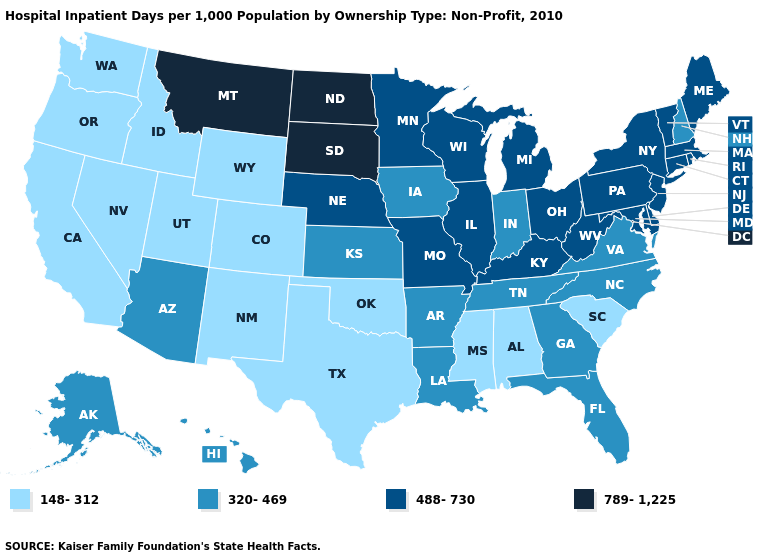Name the states that have a value in the range 789-1,225?
Give a very brief answer. Montana, North Dakota, South Dakota. Does Maryland have the highest value in the USA?
Keep it brief. No. Does Utah have the highest value in the West?
Be succinct. No. Among the states that border Missouri , does Iowa have the highest value?
Quick response, please. No. What is the highest value in states that border Massachusetts?
Quick response, please. 488-730. What is the value of New Jersey?
Keep it brief. 488-730. What is the value of Pennsylvania?
Give a very brief answer. 488-730. Name the states that have a value in the range 488-730?
Keep it brief. Connecticut, Delaware, Illinois, Kentucky, Maine, Maryland, Massachusetts, Michigan, Minnesota, Missouri, Nebraska, New Jersey, New York, Ohio, Pennsylvania, Rhode Island, Vermont, West Virginia, Wisconsin. What is the value of Tennessee?
Write a very short answer. 320-469. Does Montana have the highest value in the West?
Quick response, please. Yes. What is the value of Texas?
Answer briefly. 148-312. Name the states that have a value in the range 488-730?
Concise answer only. Connecticut, Delaware, Illinois, Kentucky, Maine, Maryland, Massachusetts, Michigan, Minnesota, Missouri, Nebraska, New Jersey, New York, Ohio, Pennsylvania, Rhode Island, Vermont, West Virginia, Wisconsin. What is the value of Texas?
Concise answer only. 148-312. Name the states that have a value in the range 488-730?
Quick response, please. Connecticut, Delaware, Illinois, Kentucky, Maine, Maryland, Massachusetts, Michigan, Minnesota, Missouri, Nebraska, New Jersey, New York, Ohio, Pennsylvania, Rhode Island, Vermont, West Virginia, Wisconsin. 